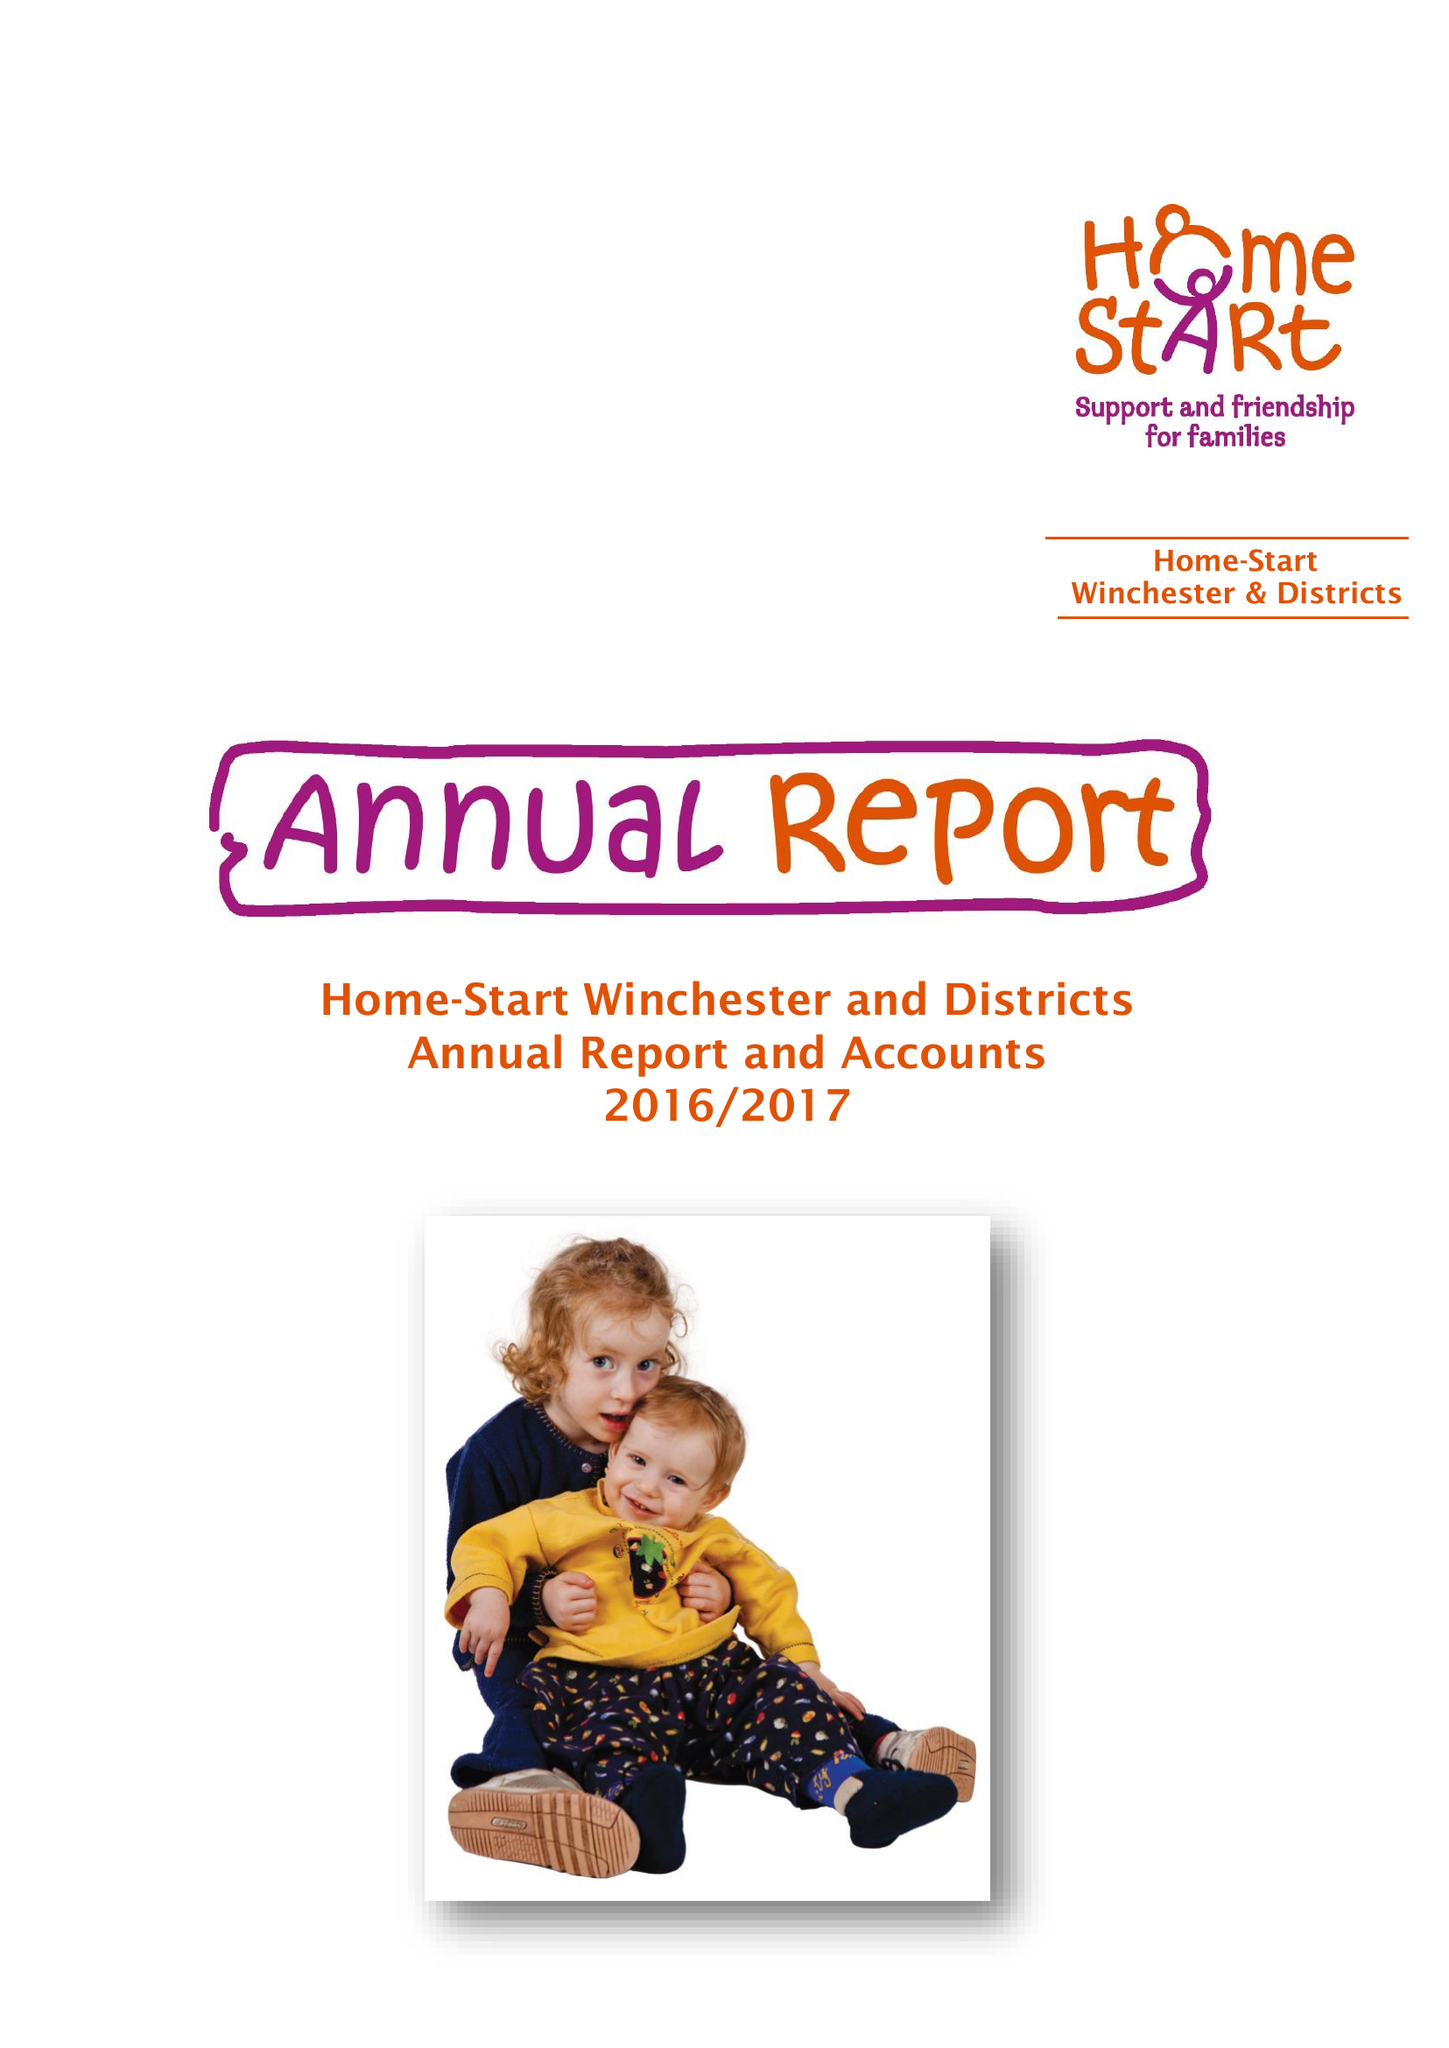What is the value for the charity_number?
Answer the question using a single word or phrase. 1108170 